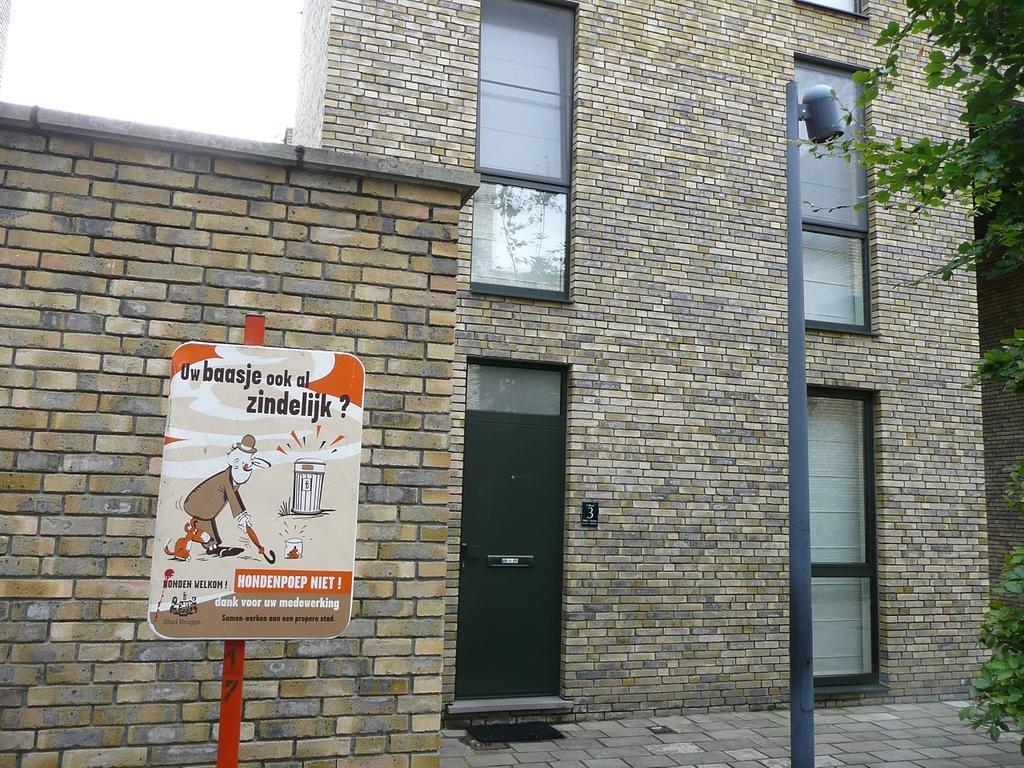How would you summarize this image in a sentence or two? In this image I see a building and I see the windows and the door over here and I see the pole. I can also see a board over here on which there are words and a cartoon character over here and I see the green leaves and I see the path. 